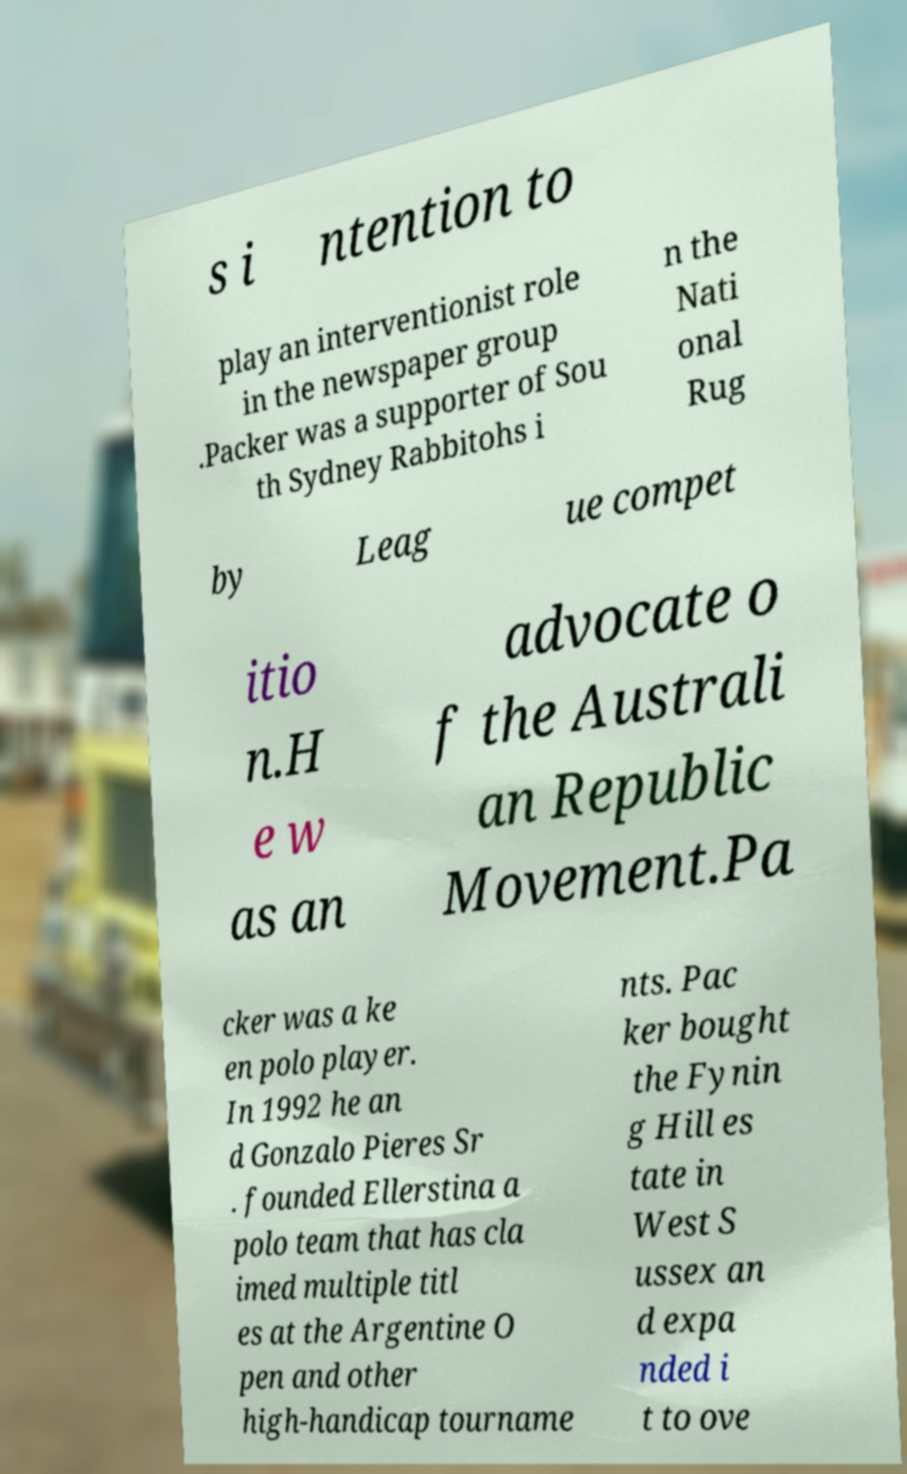Please read and relay the text visible in this image. What does it say? s i ntention to play an interventionist role in the newspaper group .Packer was a supporter of Sou th Sydney Rabbitohs i n the Nati onal Rug by Leag ue compet itio n.H e w as an advocate o f the Australi an Republic Movement.Pa cker was a ke en polo player. In 1992 he an d Gonzalo Pieres Sr . founded Ellerstina a polo team that has cla imed multiple titl es at the Argentine O pen and other high-handicap tourname nts. Pac ker bought the Fynin g Hill es tate in West S ussex an d expa nded i t to ove 